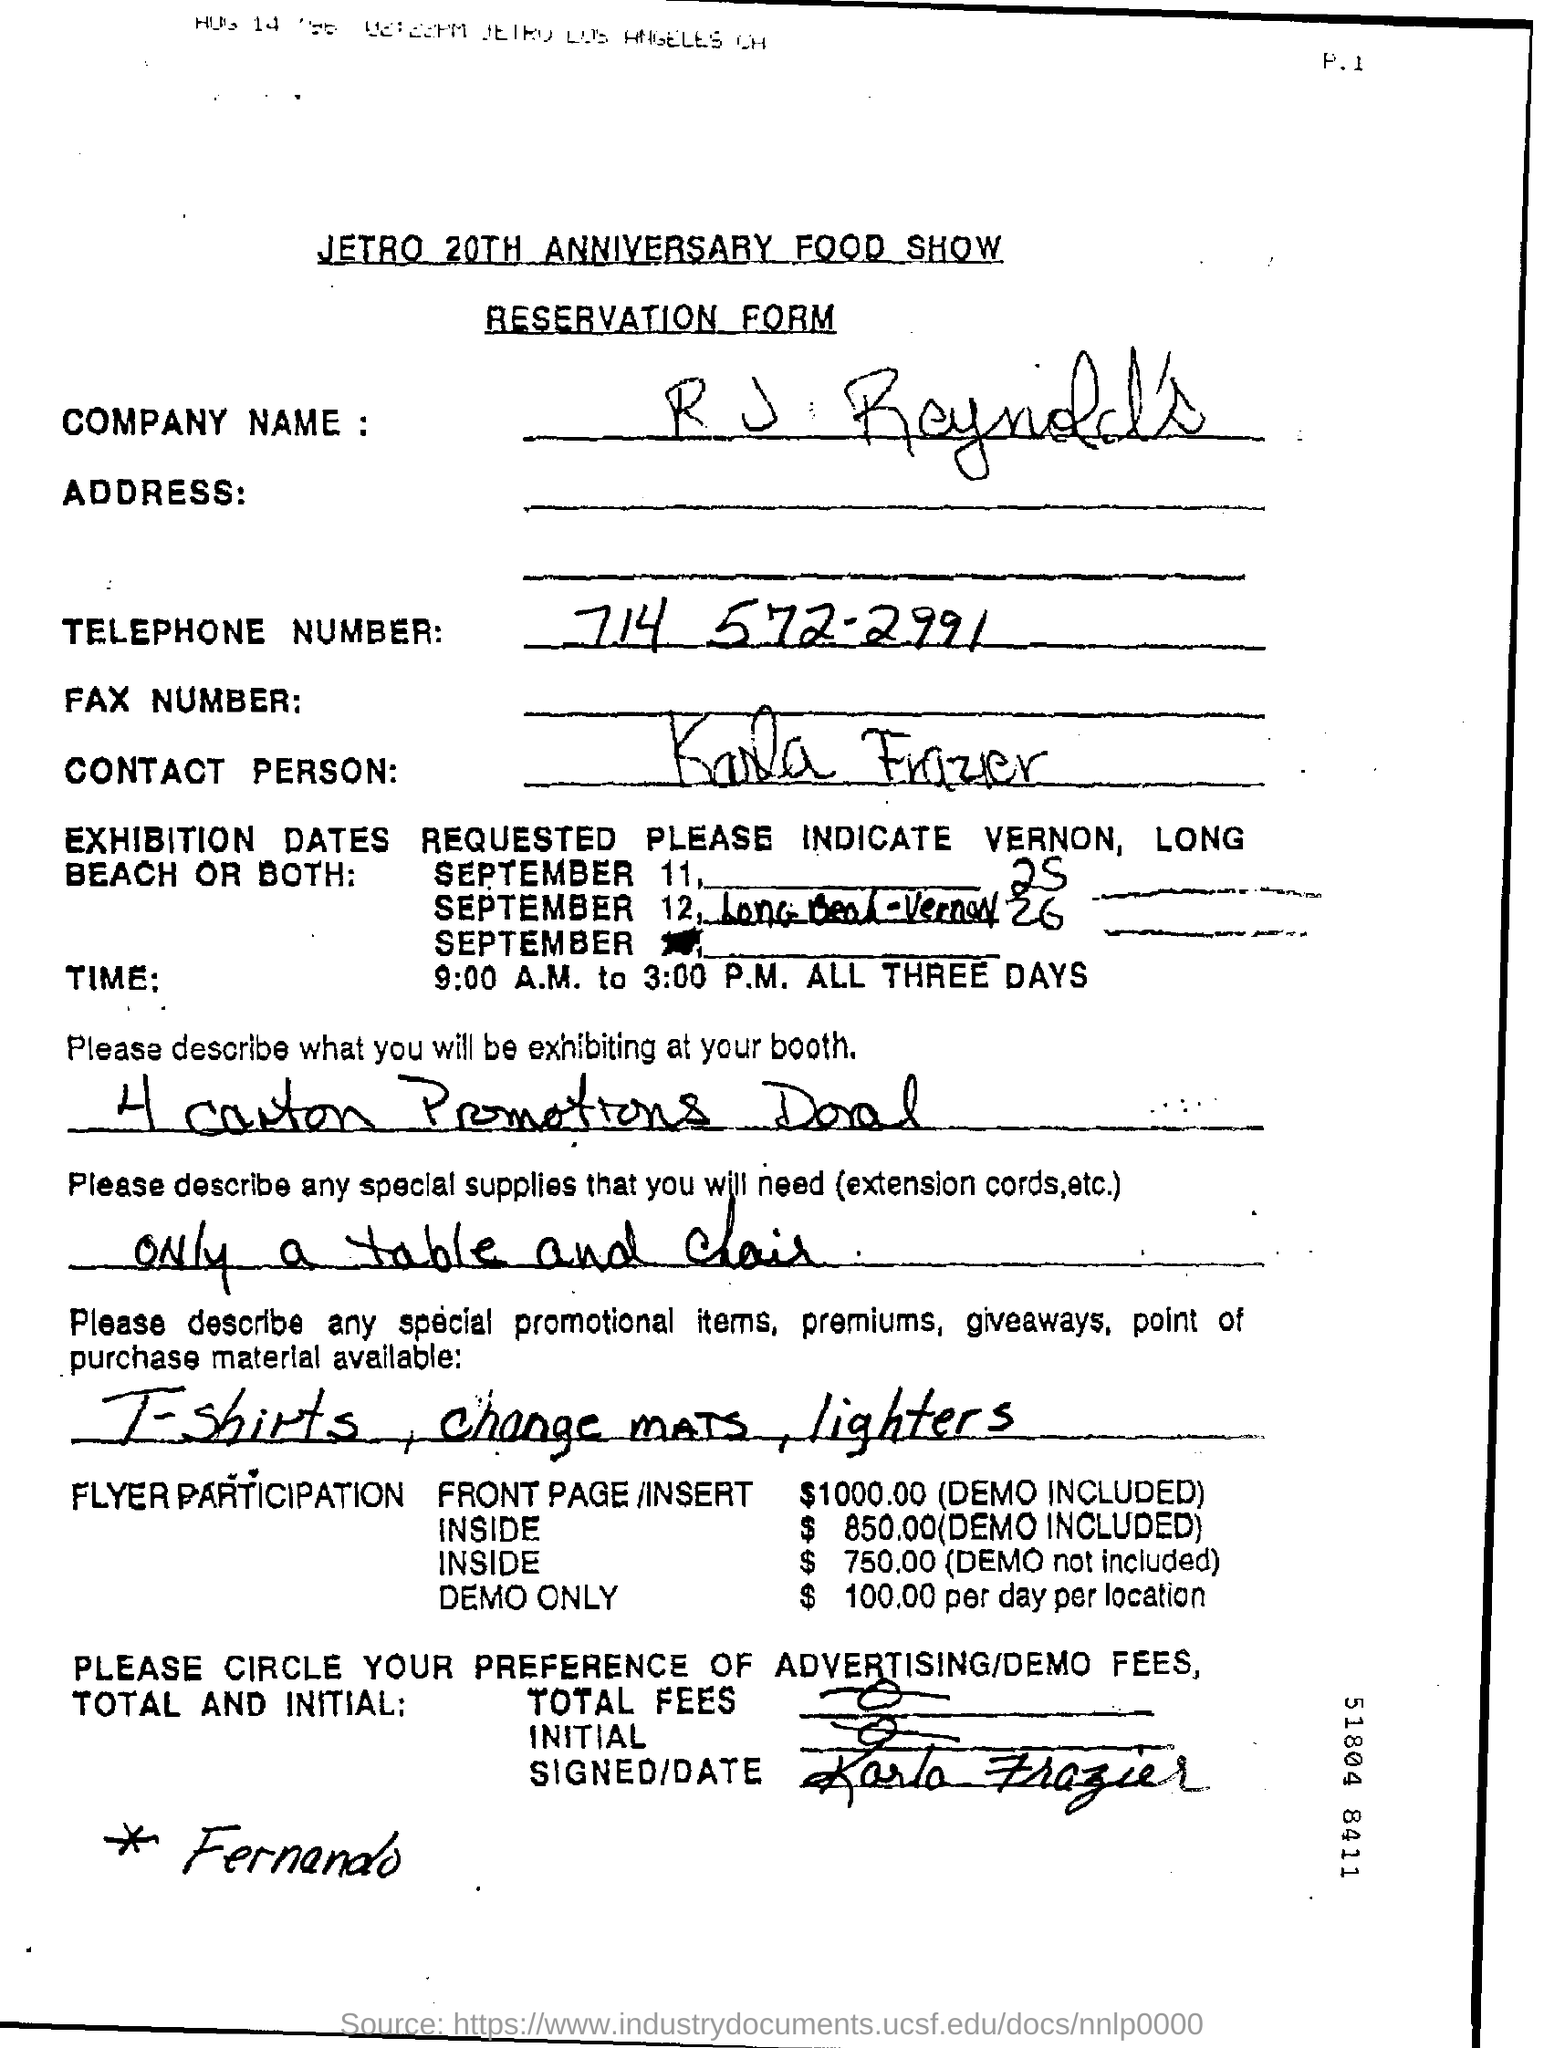Indicate a few pertinent items in this graphic. The telephone number mentioned in the form is 714 572-2991. The cost for participating in the flyer demo is $100.00. The exhibition will take place from 9:00 A.M. to 3:00 P.M. The exhibition will commence on September 11. 